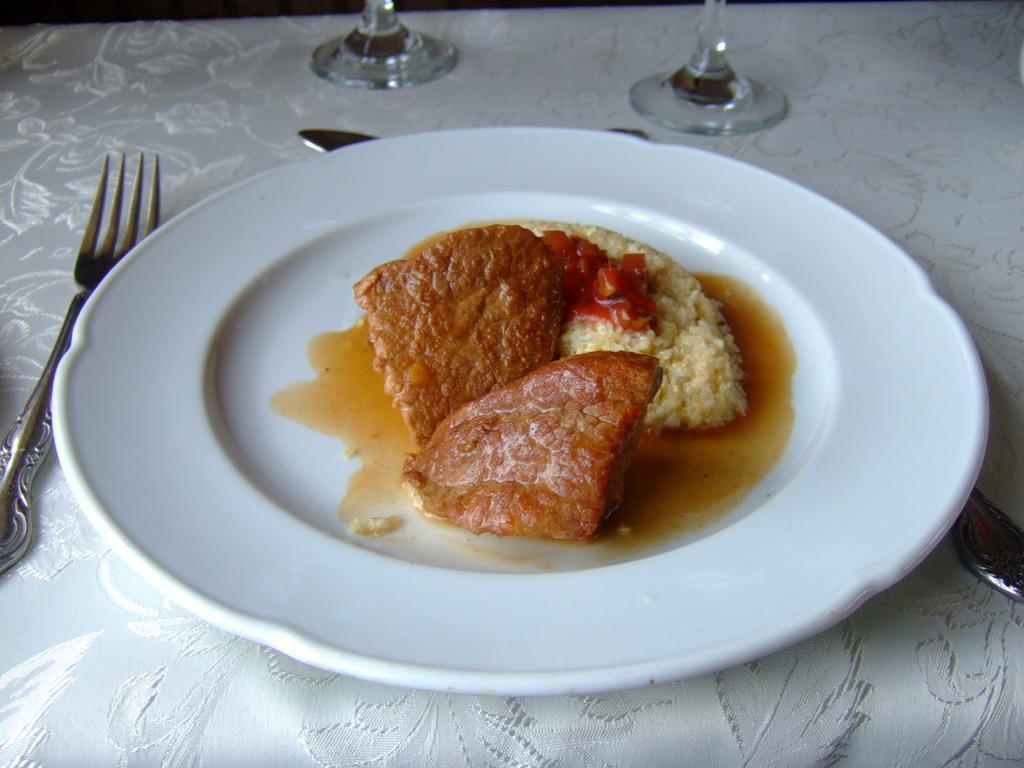Please provide a concise description of this image. In this image I can see the food in the white color plate. I can see the fork, few glass objects on the white color cloth. The food is in brown, red and white color. 